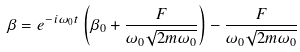Convert formula to latex. <formula><loc_0><loc_0><loc_500><loc_500>\beta = e ^ { - i \omega _ { 0 } t } \left ( \beta _ { 0 } + \frac { F } { \omega _ { 0 } \sqrt { 2 m \omega _ { 0 } } } \right ) - \frac { F } { \omega _ { 0 } \sqrt { 2 m \omega _ { 0 } } }</formula> 